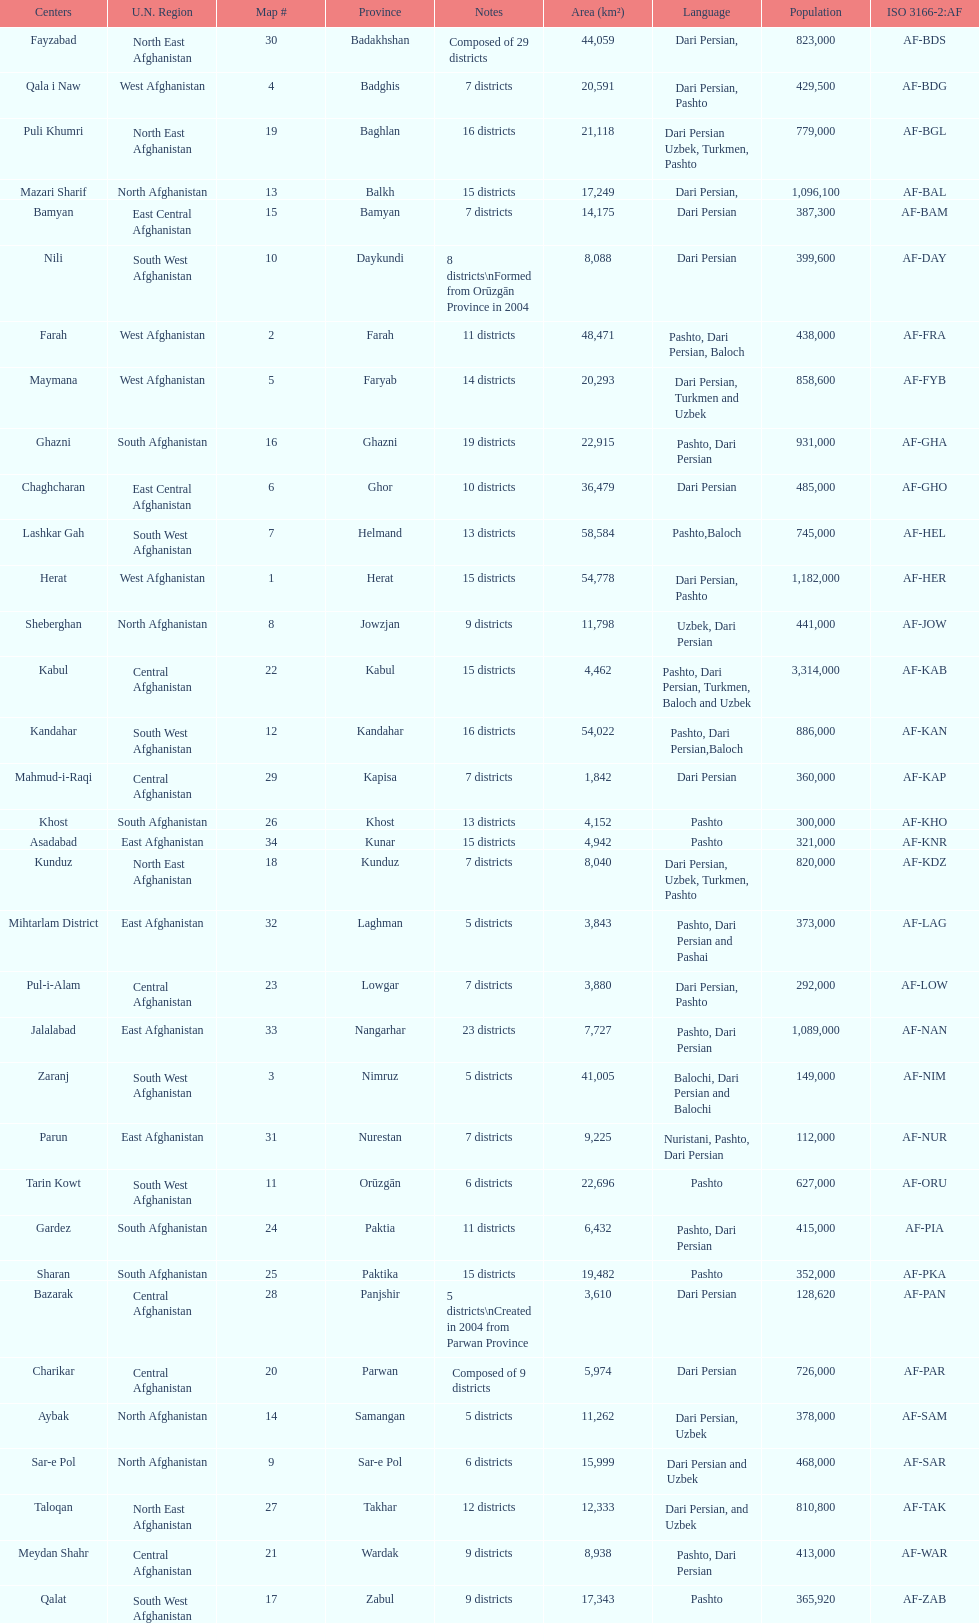How many provinces have the same number of districts as kabul? 4. 